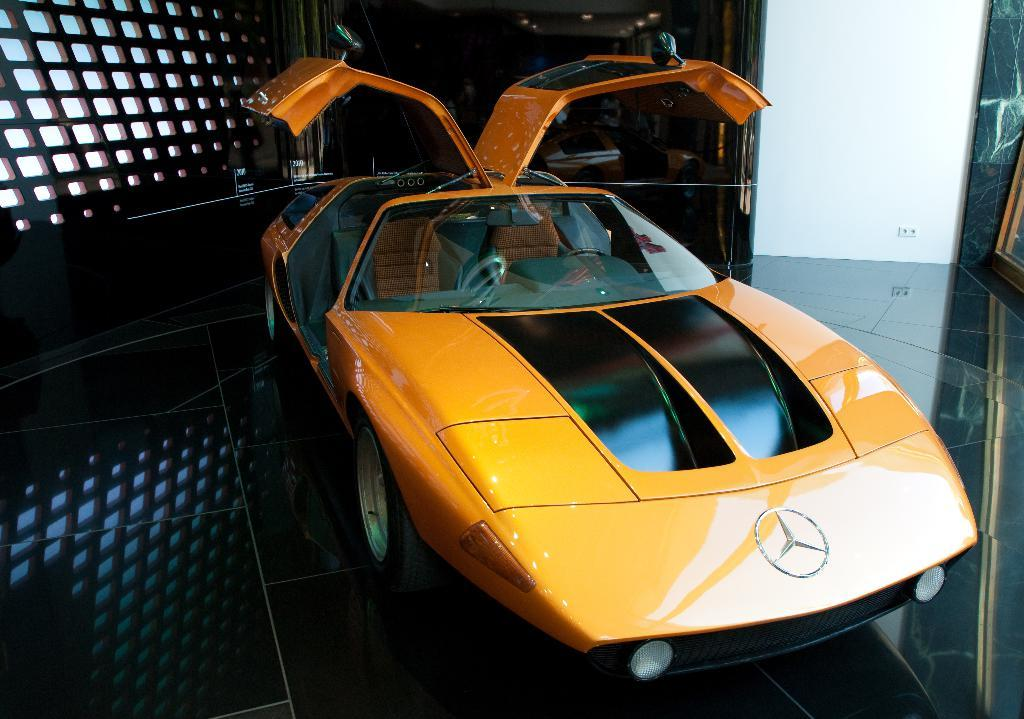What is the main subject of the image? The main subject of the image is a car. What is the state of the car doors in the image? The car doors are opened in the image. Where is the car located in the image? The car is on a platform in the image. What can be seen in the background of the image? There is a window in the background of the image. What type of pickle is being used to fix the car in the image? There is no pickle present in the image, and therefore no such activity can be observed. 